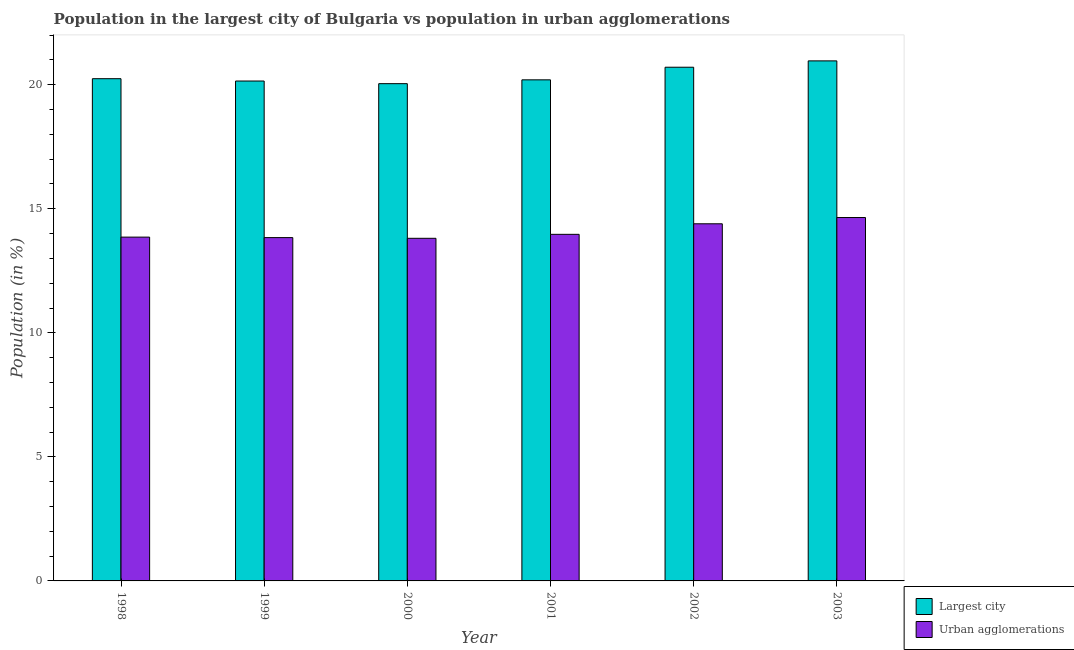Are the number of bars per tick equal to the number of legend labels?
Offer a terse response. Yes. How many bars are there on the 1st tick from the right?
Provide a succinct answer. 2. What is the label of the 1st group of bars from the left?
Provide a short and direct response. 1998. In how many cases, is the number of bars for a given year not equal to the number of legend labels?
Your answer should be compact. 0. What is the population in urban agglomerations in 1999?
Your response must be concise. 13.84. Across all years, what is the maximum population in urban agglomerations?
Offer a terse response. 14.65. Across all years, what is the minimum population in urban agglomerations?
Provide a succinct answer. 13.81. What is the total population in the largest city in the graph?
Provide a short and direct response. 122.3. What is the difference between the population in the largest city in 2001 and that in 2003?
Ensure brevity in your answer.  -0.76. What is the difference between the population in urban agglomerations in 2000 and the population in the largest city in 2002?
Provide a short and direct response. -0.59. What is the average population in the largest city per year?
Your response must be concise. 20.38. In the year 2001, what is the difference between the population in the largest city and population in urban agglomerations?
Your answer should be very brief. 0. In how many years, is the population in the largest city greater than 21 %?
Keep it short and to the point. 0. What is the ratio of the population in the largest city in 1999 to that in 2003?
Your answer should be very brief. 0.96. Is the population in urban agglomerations in 2000 less than that in 2003?
Offer a very short reply. Yes. What is the difference between the highest and the second highest population in urban agglomerations?
Offer a very short reply. 0.25. What is the difference between the highest and the lowest population in the largest city?
Make the answer very short. 0.92. Is the sum of the population in the largest city in 1998 and 2002 greater than the maximum population in urban agglomerations across all years?
Offer a very short reply. Yes. What does the 2nd bar from the left in 1998 represents?
Make the answer very short. Urban agglomerations. What does the 2nd bar from the right in 2003 represents?
Keep it short and to the point. Largest city. How many bars are there?
Your response must be concise. 12. Are the values on the major ticks of Y-axis written in scientific E-notation?
Your answer should be very brief. No. Does the graph contain any zero values?
Offer a terse response. No. Where does the legend appear in the graph?
Keep it short and to the point. Bottom right. How many legend labels are there?
Give a very brief answer. 2. What is the title of the graph?
Offer a very short reply. Population in the largest city of Bulgaria vs population in urban agglomerations. What is the label or title of the Y-axis?
Give a very brief answer. Population (in %). What is the Population (in %) in Largest city in 1998?
Your answer should be compact. 20.24. What is the Population (in %) of Urban agglomerations in 1998?
Your response must be concise. 13.86. What is the Population (in %) in Largest city in 1999?
Make the answer very short. 20.15. What is the Population (in %) of Urban agglomerations in 1999?
Provide a short and direct response. 13.84. What is the Population (in %) of Largest city in 2000?
Give a very brief answer. 20.04. What is the Population (in %) in Urban agglomerations in 2000?
Make the answer very short. 13.81. What is the Population (in %) in Largest city in 2001?
Your answer should be very brief. 20.2. What is the Population (in %) of Urban agglomerations in 2001?
Your answer should be compact. 13.97. What is the Population (in %) of Largest city in 2002?
Give a very brief answer. 20.71. What is the Population (in %) in Urban agglomerations in 2002?
Your answer should be compact. 14.4. What is the Population (in %) in Largest city in 2003?
Provide a short and direct response. 20.96. What is the Population (in %) of Urban agglomerations in 2003?
Make the answer very short. 14.65. Across all years, what is the maximum Population (in %) in Largest city?
Make the answer very short. 20.96. Across all years, what is the maximum Population (in %) in Urban agglomerations?
Your answer should be compact. 14.65. Across all years, what is the minimum Population (in %) of Largest city?
Make the answer very short. 20.04. Across all years, what is the minimum Population (in %) of Urban agglomerations?
Make the answer very short. 13.81. What is the total Population (in %) in Largest city in the graph?
Provide a succinct answer. 122.3. What is the total Population (in %) in Urban agglomerations in the graph?
Ensure brevity in your answer.  84.52. What is the difference between the Population (in %) in Largest city in 1998 and that in 1999?
Keep it short and to the point. 0.09. What is the difference between the Population (in %) of Urban agglomerations in 1998 and that in 1999?
Make the answer very short. 0.02. What is the difference between the Population (in %) of Largest city in 1998 and that in 2000?
Give a very brief answer. 0.2. What is the difference between the Population (in %) of Urban agglomerations in 1998 and that in 2000?
Provide a succinct answer. 0.05. What is the difference between the Population (in %) in Largest city in 1998 and that in 2001?
Make the answer very short. 0.05. What is the difference between the Population (in %) of Urban agglomerations in 1998 and that in 2001?
Make the answer very short. -0.11. What is the difference between the Population (in %) of Largest city in 1998 and that in 2002?
Make the answer very short. -0.46. What is the difference between the Population (in %) of Urban agglomerations in 1998 and that in 2002?
Your answer should be very brief. -0.54. What is the difference between the Population (in %) in Largest city in 1998 and that in 2003?
Your response must be concise. -0.72. What is the difference between the Population (in %) of Urban agglomerations in 1998 and that in 2003?
Offer a terse response. -0.79. What is the difference between the Population (in %) in Largest city in 1999 and that in 2000?
Provide a short and direct response. 0.11. What is the difference between the Population (in %) of Urban agglomerations in 1999 and that in 2000?
Give a very brief answer. 0.03. What is the difference between the Population (in %) in Largest city in 1999 and that in 2001?
Provide a short and direct response. -0.05. What is the difference between the Population (in %) of Urban agglomerations in 1999 and that in 2001?
Provide a short and direct response. -0.13. What is the difference between the Population (in %) in Largest city in 1999 and that in 2002?
Give a very brief answer. -0.56. What is the difference between the Population (in %) of Urban agglomerations in 1999 and that in 2002?
Offer a very short reply. -0.56. What is the difference between the Population (in %) in Largest city in 1999 and that in 2003?
Keep it short and to the point. -0.81. What is the difference between the Population (in %) of Urban agglomerations in 1999 and that in 2003?
Your answer should be very brief. -0.81. What is the difference between the Population (in %) in Largest city in 2000 and that in 2001?
Your response must be concise. -0.15. What is the difference between the Population (in %) of Urban agglomerations in 2000 and that in 2001?
Provide a short and direct response. -0.16. What is the difference between the Population (in %) of Largest city in 2000 and that in 2002?
Make the answer very short. -0.66. What is the difference between the Population (in %) of Urban agglomerations in 2000 and that in 2002?
Provide a short and direct response. -0.59. What is the difference between the Population (in %) in Largest city in 2000 and that in 2003?
Give a very brief answer. -0.92. What is the difference between the Population (in %) in Urban agglomerations in 2000 and that in 2003?
Give a very brief answer. -0.84. What is the difference between the Population (in %) in Largest city in 2001 and that in 2002?
Provide a succinct answer. -0.51. What is the difference between the Population (in %) of Urban agglomerations in 2001 and that in 2002?
Provide a short and direct response. -0.43. What is the difference between the Population (in %) in Largest city in 2001 and that in 2003?
Provide a succinct answer. -0.76. What is the difference between the Population (in %) of Urban agglomerations in 2001 and that in 2003?
Your answer should be very brief. -0.68. What is the difference between the Population (in %) in Largest city in 2002 and that in 2003?
Provide a succinct answer. -0.26. What is the difference between the Population (in %) in Urban agglomerations in 2002 and that in 2003?
Give a very brief answer. -0.25. What is the difference between the Population (in %) of Largest city in 1998 and the Population (in %) of Urban agglomerations in 1999?
Your answer should be very brief. 6.41. What is the difference between the Population (in %) in Largest city in 1998 and the Population (in %) in Urban agglomerations in 2000?
Your answer should be very brief. 6.43. What is the difference between the Population (in %) in Largest city in 1998 and the Population (in %) in Urban agglomerations in 2001?
Provide a succinct answer. 6.27. What is the difference between the Population (in %) in Largest city in 1998 and the Population (in %) in Urban agglomerations in 2002?
Your response must be concise. 5.85. What is the difference between the Population (in %) in Largest city in 1998 and the Population (in %) in Urban agglomerations in 2003?
Make the answer very short. 5.6. What is the difference between the Population (in %) in Largest city in 1999 and the Population (in %) in Urban agglomerations in 2000?
Make the answer very short. 6.34. What is the difference between the Population (in %) in Largest city in 1999 and the Population (in %) in Urban agglomerations in 2001?
Your response must be concise. 6.18. What is the difference between the Population (in %) of Largest city in 1999 and the Population (in %) of Urban agglomerations in 2002?
Give a very brief answer. 5.75. What is the difference between the Population (in %) in Largest city in 1999 and the Population (in %) in Urban agglomerations in 2003?
Your response must be concise. 5.5. What is the difference between the Population (in %) of Largest city in 2000 and the Population (in %) of Urban agglomerations in 2001?
Your answer should be compact. 6.07. What is the difference between the Population (in %) of Largest city in 2000 and the Population (in %) of Urban agglomerations in 2002?
Your response must be concise. 5.65. What is the difference between the Population (in %) in Largest city in 2000 and the Population (in %) in Urban agglomerations in 2003?
Your answer should be compact. 5.4. What is the difference between the Population (in %) of Largest city in 2001 and the Population (in %) of Urban agglomerations in 2002?
Provide a succinct answer. 5.8. What is the difference between the Population (in %) in Largest city in 2001 and the Population (in %) in Urban agglomerations in 2003?
Provide a succinct answer. 5.55. What is the difference between the Population (in %) in Largest city in 2002 and the Population (in %) in Urban agglomerations in 2003?
Your answer should be very brief. 6.06. What is the average Population (in %) in Largest city per year?
Provide a succinct answer. 20.38. What is the average Population (in %) of Urban agglomerations per year?
Make the answer very short. 14.09. In the year 1998, what is the difference between the Population (in %) in Largest city and Population (in %) in Urban agglomerations?
Provide a short and direct response. 6.39. In the year 1999, what is the difference between the Population (in %) in Largest city and Population (in %) in Urban agglomerations?
Keep it short and to the point. 6.31. In the year 2000, what is the difference between the Population (in %) of Largest city and Population (in %) of Urban agglomerations?
Keep it short and to the point. 6.23. In the year 2001, what is the difference between the Population (in %) of Largest city and Population (in %) of Urban agglomerations?
Give a very brief answer. 6.23. In the year 2002, what is the difference between the Population (in %) of Largest city and Population (in %) of Urban agglomerations?
Ensure brevity in your answer.  6.31. In the year 2003, what is the difference between the Population (in %) in Largest city and Population (in %) in Urban agglomerations?
Your answer should be compact. 6.31. What is the ratio of the Population (in %) in Urban agglomerations in 1998 to that in 2000?
Your answer should be very brief. 1. What is the ratio of the Population (in %) of Urban agglomerations in 1998 to that in 2001?
Give a very brief answer. 0.99. What is the ratio of the Population (in %) of Largest city in 1998 to that in 2002?
Provide a succinct answer. 0.98. What is the ratio of the Population (in %) of Urban agglomerations in 1998 to that in 2002?
Your answer should be very brief. 0.96. What is the ratio of the Population (in %) of Largest city in 1998 to that in 2003?
Ensure brevity in your answer.  0.97. What is the ratio of the Population (in %) of Urban agglomerations in 1998 to that in 2003?
Your answer should be compact. 0.95. What is the ratio of the Population (in %) of Urban agglomerations in 1999 to that in 2000?
Ensure brevity in your answer.  1. What is the ratio of the Population (in %) in Largest city in 1999 to that in 2001?
Give a very brief answer. 1. What is the ratio of the Population (in %) of Urban agglomerations in 1999 to that in 2001?
Ensure brevity in your answer.  0.99. What is the ratio of the Population (in %) of Largest city in 1999 to that in 2002?
Keep it short and to the point. 0.97. What is the ratio of the Population (in %) in Urban agglomerations in 1999 to that in 2002?
Your response must be concise. 0.96. What is the ratio of the Population (in %) in Largest city in 1999 to that in 2003?
Your answer should be compact. 0.96. What is the ratio of the Population (in %) of Urban agglomerations in 1999 to that in 2003?
Your answer should be very brief. 0.94. What is the ratio of the Population (in %) in Urban agglomerations in 2000 to that in 2001?
Provide a succinct answer. 0.99. What is the ratio of the Population (in %) of Largest city in 2000 to that in 2002?
Give a very brief answer. 0.97. What is the ratio of the Population (in %) in Urban agglomerations in 2000 to that in 2002?
Ensure brevity in your answer.  0.96. What is the ratio of the Population (in %) of Largest city in 2000 to that in 2003?
Your answer should be compact. 0.96. What is the ratio of the Population (in %) in Urban agglomerations in 2000 to that in 2003?
Your answer should be compact. 0.94. What is the ratio of the Population (in %) in Largest city in 2001 to that in 2002?
Your answer should be very brief. 0.98. What is the ratio of the Population (in %) in Urban agglomerations in 2001 to that in 2002?
Provide a succinct answer. 0.97. What is the ratio of the Population (in %) of Largest city in 2001 to that in 2003?
Keep it short and to the point. 0.96. What is the ratio of the Population (in %) in Urban agglomerations in 2001 to that in 2003?
Provide a short and direct response. 0.95. What is the ratio of the Population (in %) of Urban agglomerations in 2002 to that in 2003?
Your answer should be compact. 0.98. What is the difference between the highest and the second highest Population (in %) in Largest city?
Make the answer very short. 0.26. What is the difference between the highest and the second highest Population (in %) in Urban agglomerations?
Ensure brevity in your answer.  0.25. What is the difference between the highest and the lowest Population (in %) of Largest city?
Your answer should be very brief. 0.92. What is the difference between the highest and the lowest Population (in %) of Urban agglomerations?
Ensure brevity in your answer.  0.84. 